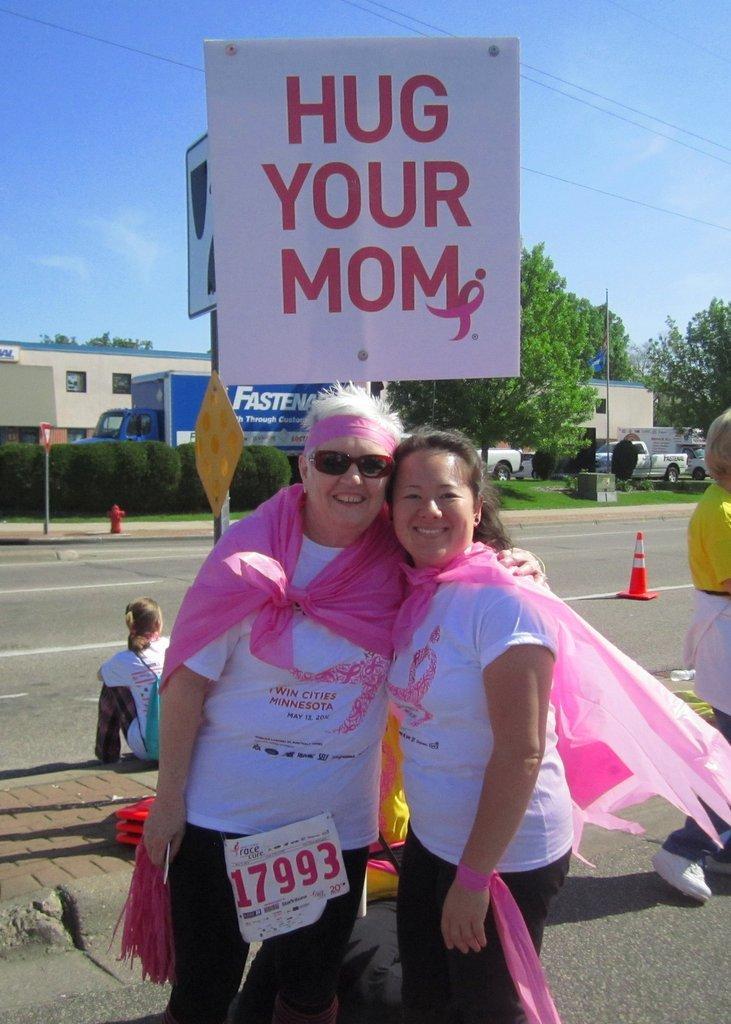Can you describe this image briefly? This is an outside view. Here I can see two persons wearing same dress, standing on the road, smiling and giving pose for the picture. On the left side there is a person sitting on the footpath facing towards the back side. On the right side one person is standing. In the background there are few vehicles, trees and buildings. At the back of these people there are two boards on which I can see the text. At the top of the image I can see the sky in blue color. 